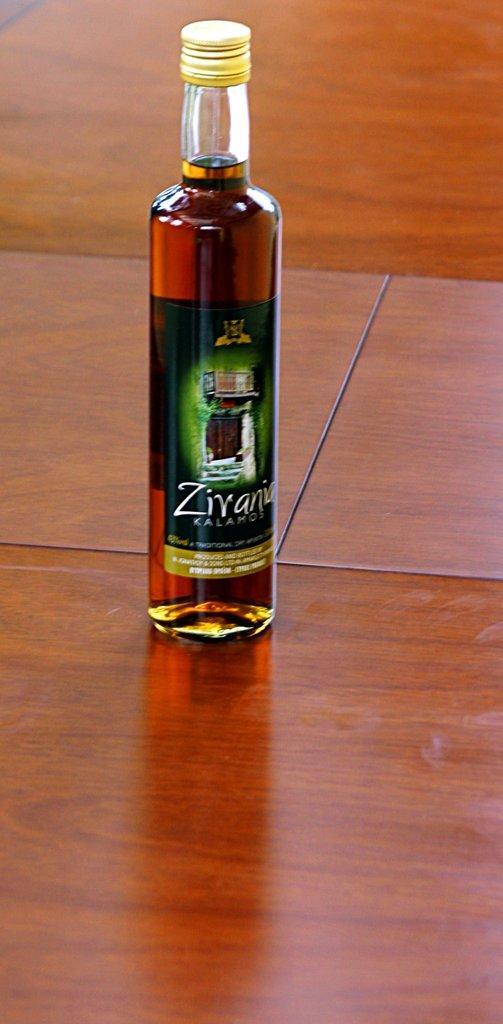Can you describe this image briefly? In this image there is a wine bottle with a label and a lid placed in a table. 